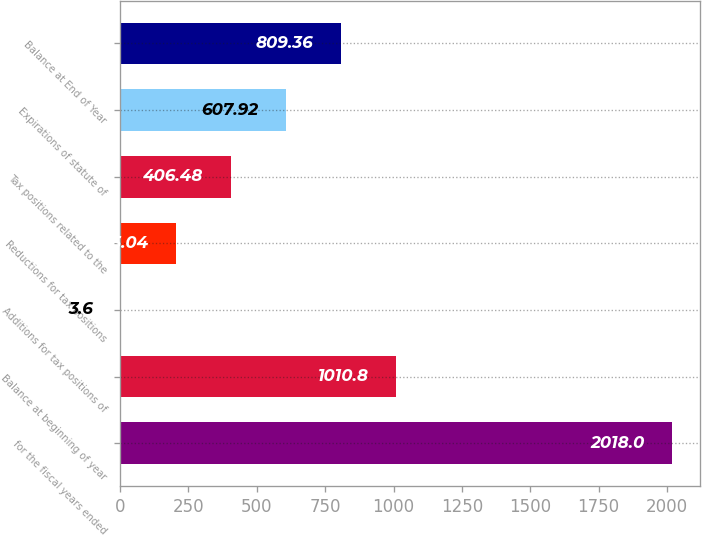Convert chart. <chart><loc_0><loc_0><loc_500><loc_500><bar_chart><fcel>for the fiscal years ended<fcel>Balance at beginning of year<fcel>Additions for tax positions of<fcel>Reductions for tax positions<fcel>Tax positions related to the<fcel>Expirations of statute of<fcel>Balance at End of Year<nl><fcel>2018<fcel>1010.8<fcel>3.6<fcel>205.04<fcel>406.48<fcel>607.92<fcel>809.36<nl></chart> 